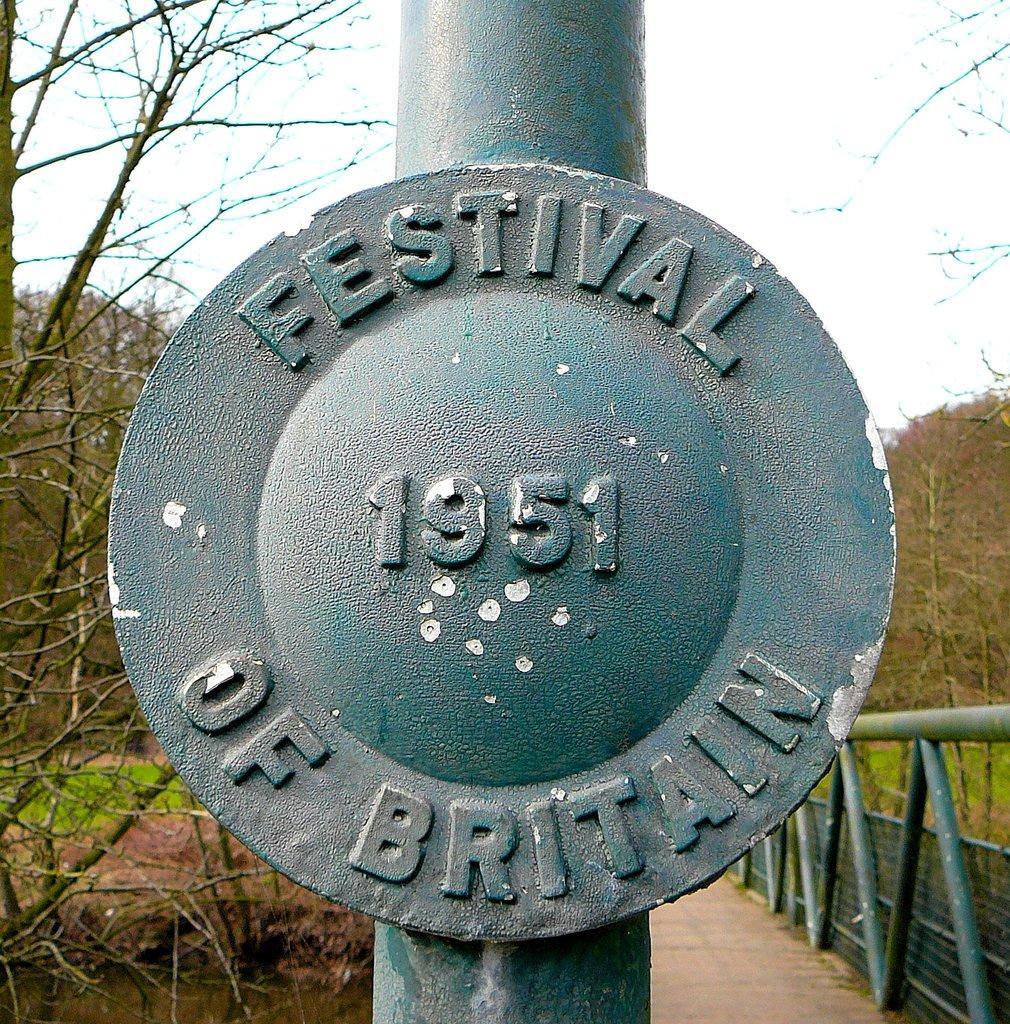Could you give a brief overview of what you see in this image? In this image we can see a pole with text and numbers. And we can see the rods, beside the road there are trees, grass and sky in the background. 